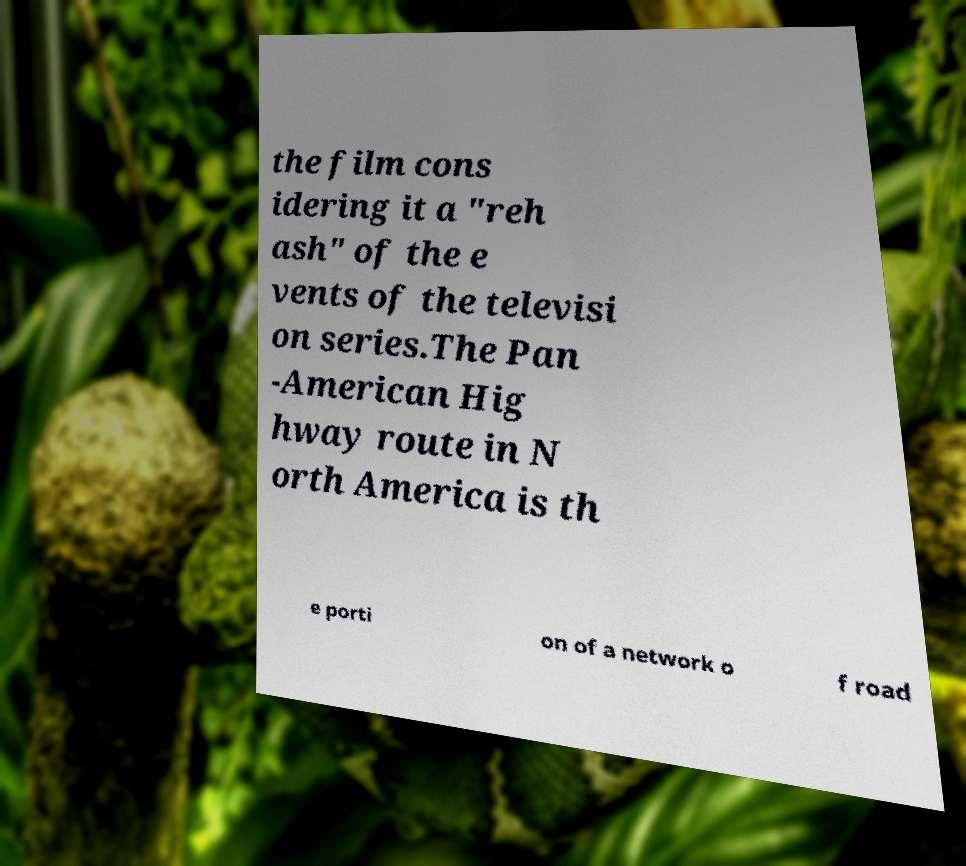There's text embedded in this image that I need extracted. Can you transcribe it verbatim? the film cons idering it a "reh ash" of the e vents of the televisi on series.The Pan -American Hig hway route in N orth America is th e porti on of a network o f road 